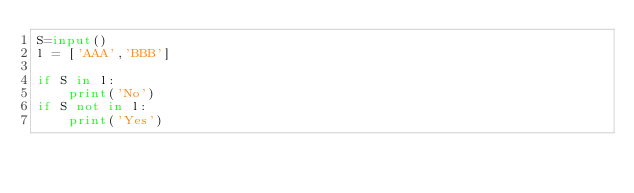<code> <loc_0><loc_0><loc_500><loc_500><_Python_>S=input()
l = ['AAA','BBB']

if S in l:
    print('No')
if S not in l:
    print('Yes')</code> 